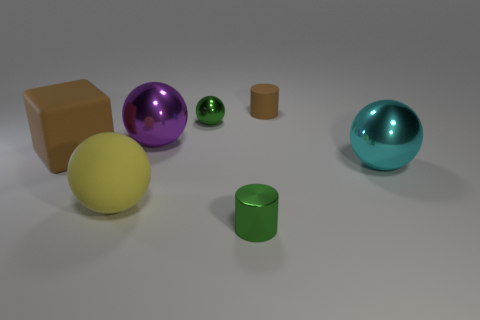Subtract 1 balls. How many balls are left? 3 Add 1 cyan things. How many objects exist? 8 Subtract all spheres. How many objects are left? 3 Subtract 0 green blocks. How many objects are left? 7 Subtract all green shiny spheres. Subtract all yellow spheres. How many objects are left? 5 Add 1 tiny metal things. How many tiny metal things are left? 3 Add 5 big purple metallic things. How many big purple metallic things exist? 6 